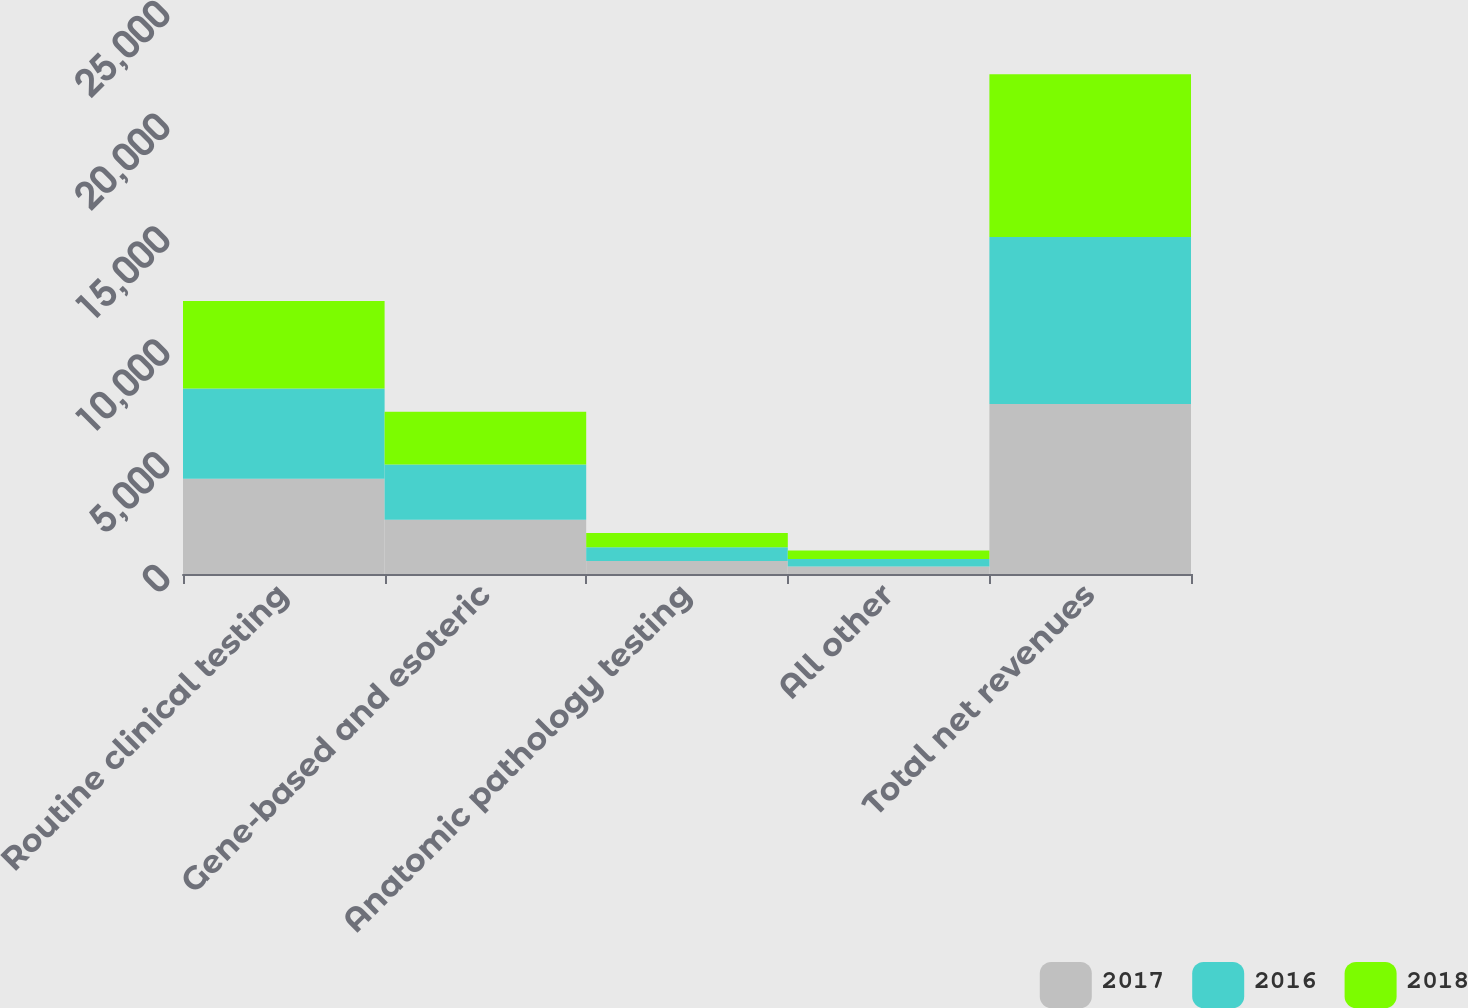Convert chart to OTSL. <chart><loc_0><loc_0><loc_500><loc_500><stacked_bar_chart><ecel><fcel>Routine clinical testing<fcel>Gene-based and esoteric<fcel>Anatomic pathology testing<fcel>All other<fcel>Total net revenues<nl><fcel>2017<fcel>4217<fcel>2409<fcel>578<fcel>327<fcel>7531<nl><fcel>2016<fcel>4006<fcel>2449<fcel>612<fcel>335<fcel>7402<nl><fcel>2018<fcel>3878<fcel>2335<fcel>624<fcel>377<fcel>7214<nl></chart> 